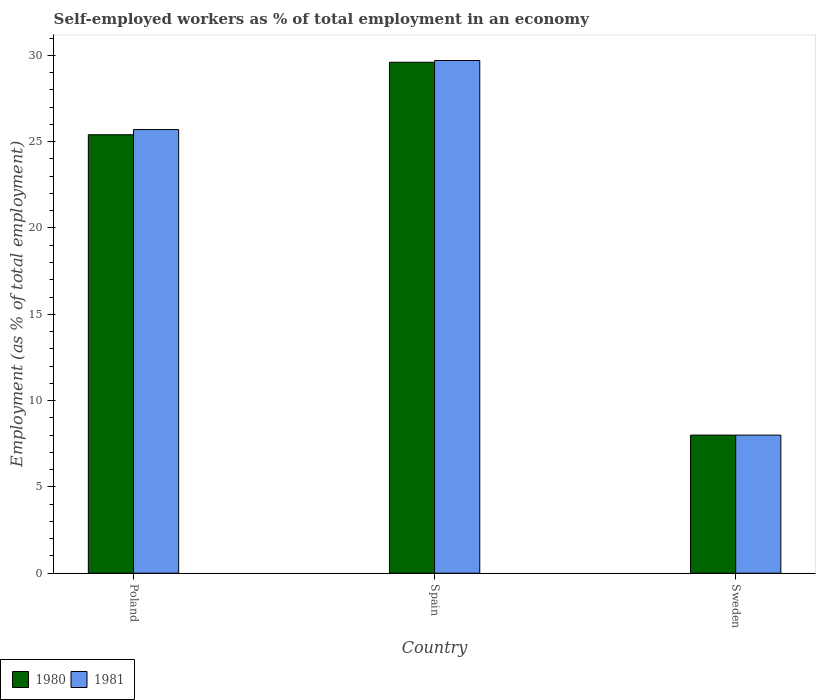How many groups of bars are there?
Provide a short and direct response. 3. Are the number of bars per tick equal to the number of legend labels?
Give a very brief answer. Yes. How many bars are there on the 3rd tick from the right?
Your response must be concise. 2. What is the label of the 3rd group of bars from the left?
Make the answer very short. Sweden. What is the percentage of self-employed workers in 1981 in Spain?
Keep it short and to the point. 29.7. Across all countries, what is the maximum percentage of self-employed workers in 1981?
Your answer should be compact. 29.7. Across all countries, what is the minimum percentage of self-employed workers in 1981?
Keep it short and to the point. 8. In which country was the percentage of self-employed workers in 1980 maximum?
Keep it short and to the point. Spain. What is the total percentage of self-employed workers in 1981 in the graph?
Offer a very short reply. 63.4. What is the difference between the percentage of self-employed workers in 1981 in Spain and that in Sweden?
Offer a very short reply. 21.7. What is the difference between the percentage of self-employed workers in 1980 in Poland and the percentage of self-employed workers in 1981 in Spain?
Offer a very short reply. -4.3. What is the difference between the percentage of self-employed workers of/in 1981 and percentage of self-employed workers of/in 1980 in Poland?
Give a very brief answer. 0.3. In how many countries, is the percentage of self-employed workers in 1981 greater than 3 %?
Offer a terse response. 3. What is the ratio of the percentage of self-employed workers in 1980 in Poland to that in Spain?
Give a very brief answer. 0.86. Is the percentage of self-employed workers in 1980 in Poland less than that in Spain?
Offer a terse response. Yes. Is the difference between the percentage of self-employed workers in 1981 in Poland and Spain greater than the difference between the percentage of self-employed workers in 1980 in Poland and Spain?
Offer a very short reply. Yes. What is the difference between the highest and the second highest percentage of self-employed workers in 1981?
Give a very brief answer. -17.7. What is the difference between the highest and the lowest percentage of self-employed workers in 1980?
Your response must be concise. 21.6. Is the sum of the percentage of self-employed workers in 1981 in Spain and Sweden greater than the maximum percentage of self-employed workers in 1980 across all countries?
Keep it short and to the point. Yes. What does the 1st bar from the right in Poland represents?
Offer a terse response. 1981. How many bars are there?
Keep it short and to the point. 6. Are all the bars in the graph horizontal?
Give a very brief answer. No. How many countries are there in the graph?
Make the answer very short. 3. Are the values on the major ticks of Y-axis written in scientific E-notation?
Keep it short and to the point. No. Does the graph contain any zero values?
Your response must be concise. No. Does the graph contain grids?
Keep it short and to the point. No. What is the title of the graph?
Your answer should be compact. Self-employed workers as % of total employment in an economy. Does "1986" appear as one of the legend labels in the graph?
Give a very brief answer. No. What is the label or title of the Y-axis?
Provide a succinct answer. Employment (as % of total employment). What is the Employment (as % of total employment) of 1980 in Poland?
Ensure brevity in your answer.  25.4. What is the Employment (as % of total employment) in 1981 in Poland?
Offer a very short reply. 25.7. What is the Employment (as % of total employment) of 1980 in Spain?
Your response must be concise. 29.6. What is the Employment (as % of total employment) of 1981 in Spain?
Offer a very short reply. 29.7. What is the Employment (as % of total employment) in 1980 in Sweden?
Your answer should be compact. 8. What is the Employment (as % of total employment) of 1981 in Sweden?
Your answer should be very brief. 8. Across all countries, what is the maximum Employment (as % of total employment) in 1980?
Your response must be concise. 29.6. Across all countries, what is the maximum Employment (as % of total employment) in 1981?
Give a very brief answer. 29.7. Across all countries, what is the minimum Employment (as % of total employment) of 1980?
Give a very brief answer. 8. Across all countries, what is the minimum Employment (as % of total employment) of 1981?
Offer a terse response. 8. What is the total Employment (as % of total employment) of 1981 in the graph?
Make the answer very short. 63.4. What is the difference between the Employment (as % of total employment) of 1980 in Poland and that in Spain?
Offer a very short reply. -4.2. What is the difference between the Employment (as % of total employment) in 1980 in Poland and that in Sweden?
Keep it short and to the point. 17.4. What is the difference between the Employment (as % of total employment) of 1981 in Poland and that in Sweden?
Offer a very short reply. 17.7. What is the difference between the Employment (as % of total employment) of 1980 in Spain and that in Sweden?
Ensure brevity in your answer.  21.6. What is the difference between the Employment (as % of total employment) in 1981 in Spain and that in Sweden?
Your answer should be very brief. 21.7. What is the difference between the Employment (as % of total employment) in 1980 in Poland and the Employment (as % of total employment) in 1981 in Sweden?
Your answer should be very brief. 17.4. What is the difference between the Employment (as % of total employment) in 1980 in Spain and the Employment (as % of total employment) in 1981 in Sweden?
Keep it short and to the point. 21.6. What is the average Employment (as % of total employment) in 1980 per country?
Offer a terse response. 21. What is the average Employment (as % of total employment) of 1981 per country?
Your answer should be compact. 21.13. What is the difference between the Employment (as % of total employment) in 1980 and Employment (as % of total employment) in 1981 in Poland?
Offer a very short reply. -0.3. What is the difference between the Employment (as % of total employment) in 1980 and Employment (as % of total employment) in 1981 in Spain?
Keep it short and to the point. -0.1. What is the ratio of the Employment (as % of total employment) of 1980 in Poland to that in Spain?
Provide a short and direct response. 0.86. What is the ratio of the Employment (as % of total employment) of 1981 in Poland to that in Spain?
Keep it short and to the point. 0.87. What is the ratio of the Employment (as % of total employment) of 1980 in Poland to that in Sweden?
Your answer should be compact. 3.17. What is the ratio of the Employment (as % of total employment) in 1981 in Poland to that in Sweden?
Offer a terse response. 3.21. What is the ratio of the Employment (as % of total employment) of 1981 in Spain to that in Sweden?
Make the answer very short. 3.71. What is the difference between the highest and the second highest Employment (as % of total employment) of 1980?
Ensure brevity in your answer.  4.2. What is the difference between the highest and the second highest Employment (as % of total employment) in 1981?
Make the answer very short. 4. What is the difference between the highest and the lowest Employment (as % of total employment) in 1980?
Your response must be concise. 21.6. What is the difference between the highest and the lowest Employment (as % of total employment) of 1981?
Offer a terse response. 21.7. 